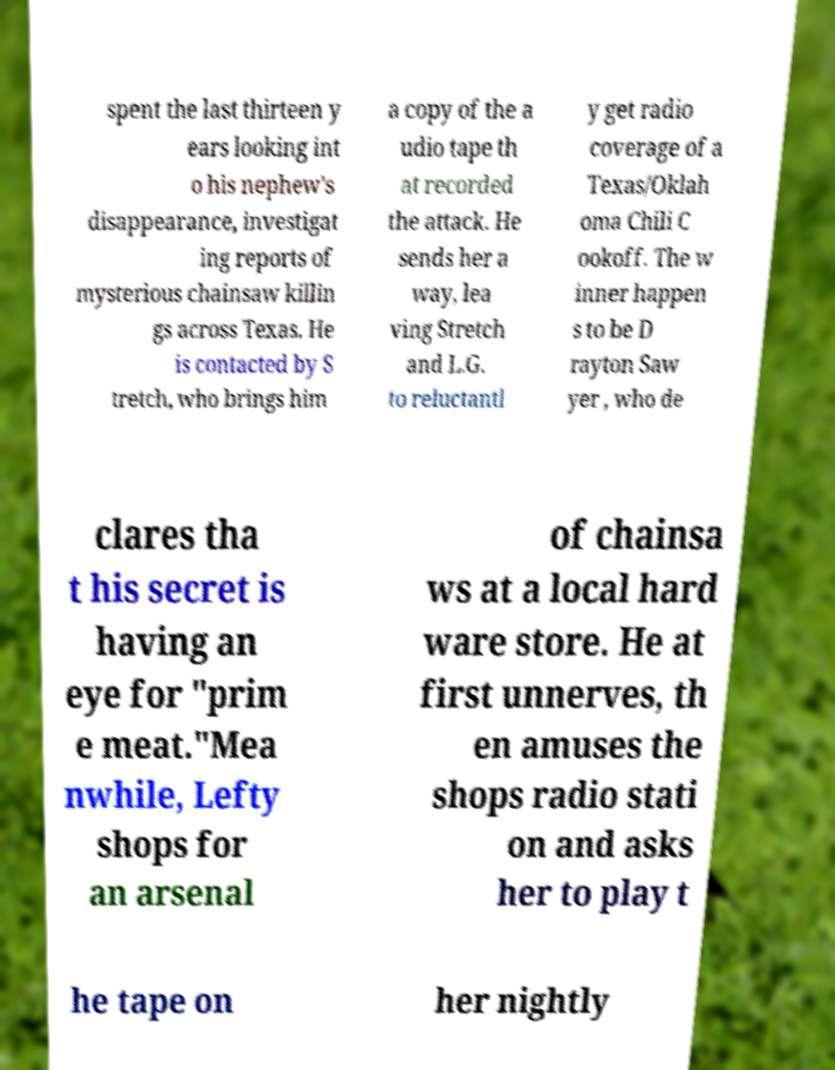Could you assist in decoding the text presented in this image and type it out clearly? spent the last thirteen y ears looking int o his nephew's disappearance, investigat ing reports of mysterious chainsaw killin gs across Texas. He is contacted by S tretch, who brings him a copy of the a udio tape th at recorded the attack. He sends her a way, lea ving Stretch and L.G. to reluctantl y get radio coverage of a Texas/Oklah oma Chili C ookoff. The w inner happen s to be D rayton Saw yer , who de clares tha t his secret is having an eye for "prim e meat."Mea nwhile, Lefty shops for an arsenal of chainsa ws at a local hard ware store. He at first unnerves, th en amuses the shops radio stati on and asks her to play t he tape on her nightly 